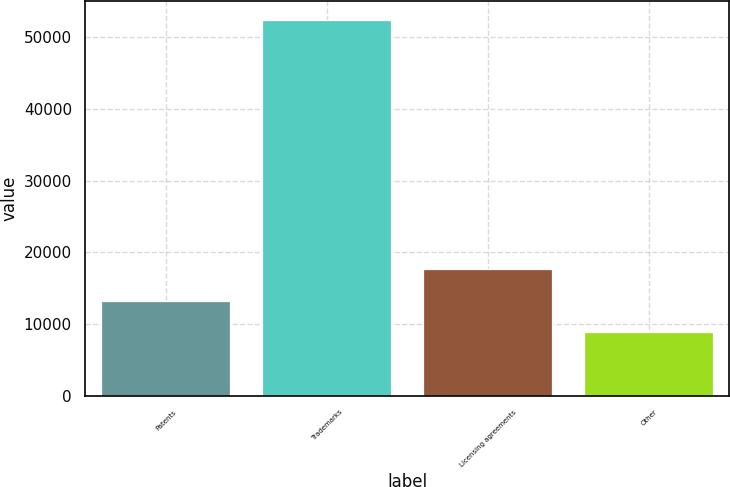<chart> <loc_0><loc_0><loc_500><loc_500><bar_chart><fcel>Patents<fcel>Trademarks<fcel>Licensing agreements<fcel>Other<nl><fcel>13280.2<fcel>52414<fcel>17628.4<fcel>8932<nl></chart> 